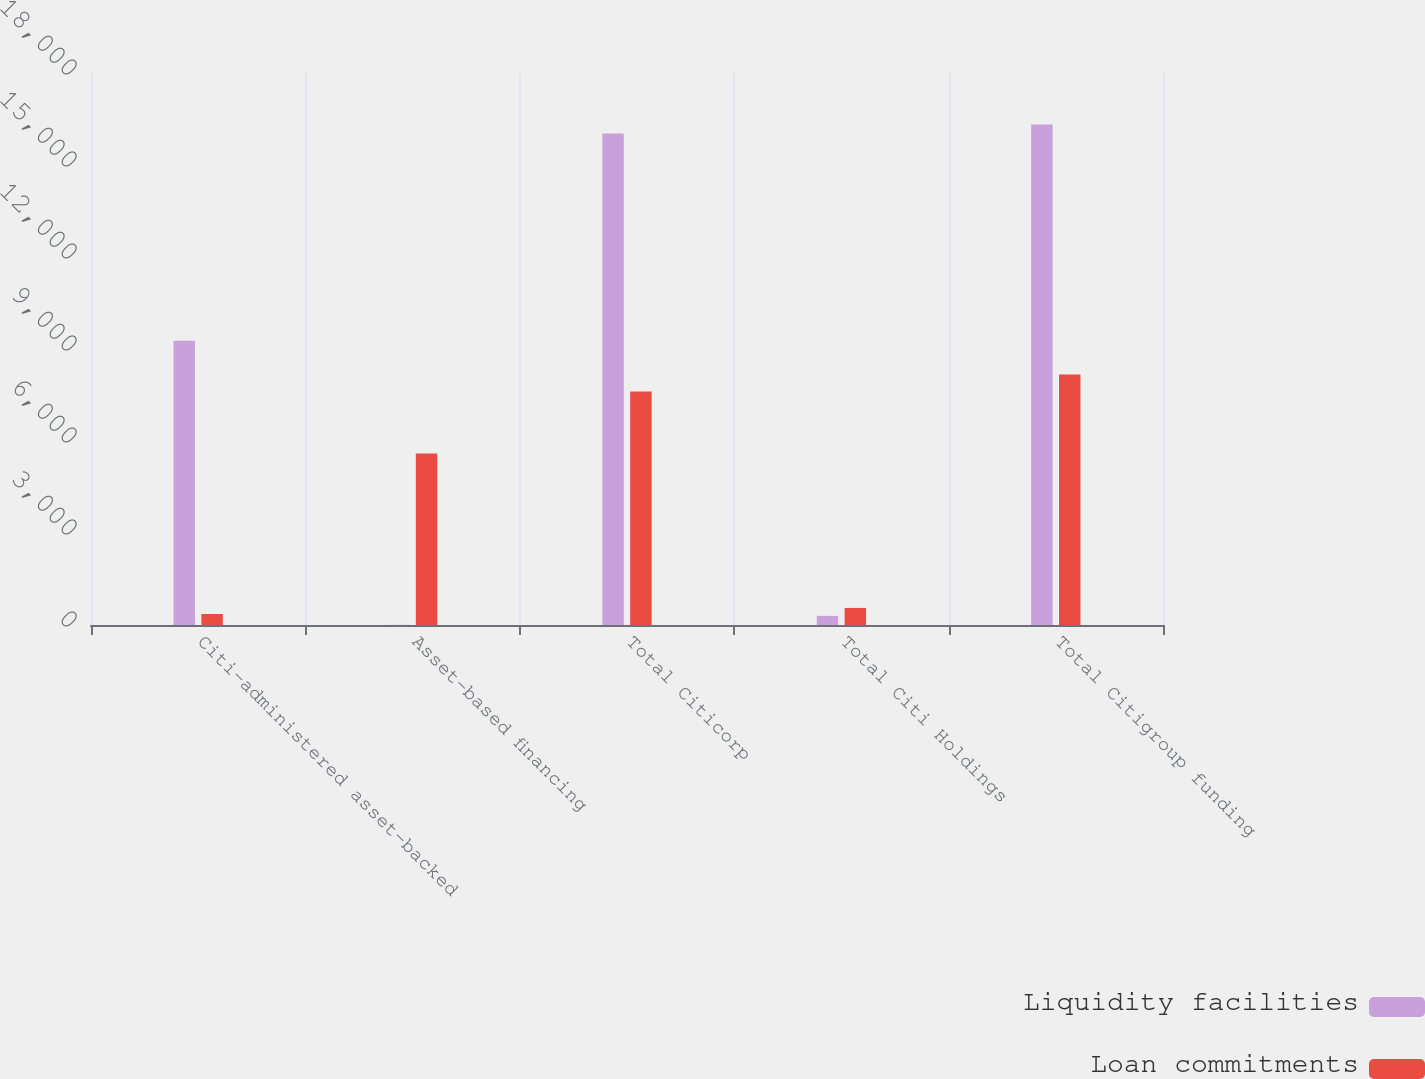<chart> <loc_0><loc_0><loc_500><loc_500><stacked_bar_chart><ecel><fcel>Citi-administered asset-backed<fcel>Asset-based financing<fcel>Total Citicorp<fcel>Total Citi Holdings<fcel>Total Citigroup funding<nl><fcel>Liquidity facilities<fcel>9270<fcel>5<fcel>16027<fcel>297<fcel>16324<nl><fcel>Loan commitments<fcel>359<fcel>5591<fcel>7613<fcel>556<fcel>8169<nl></chart> 